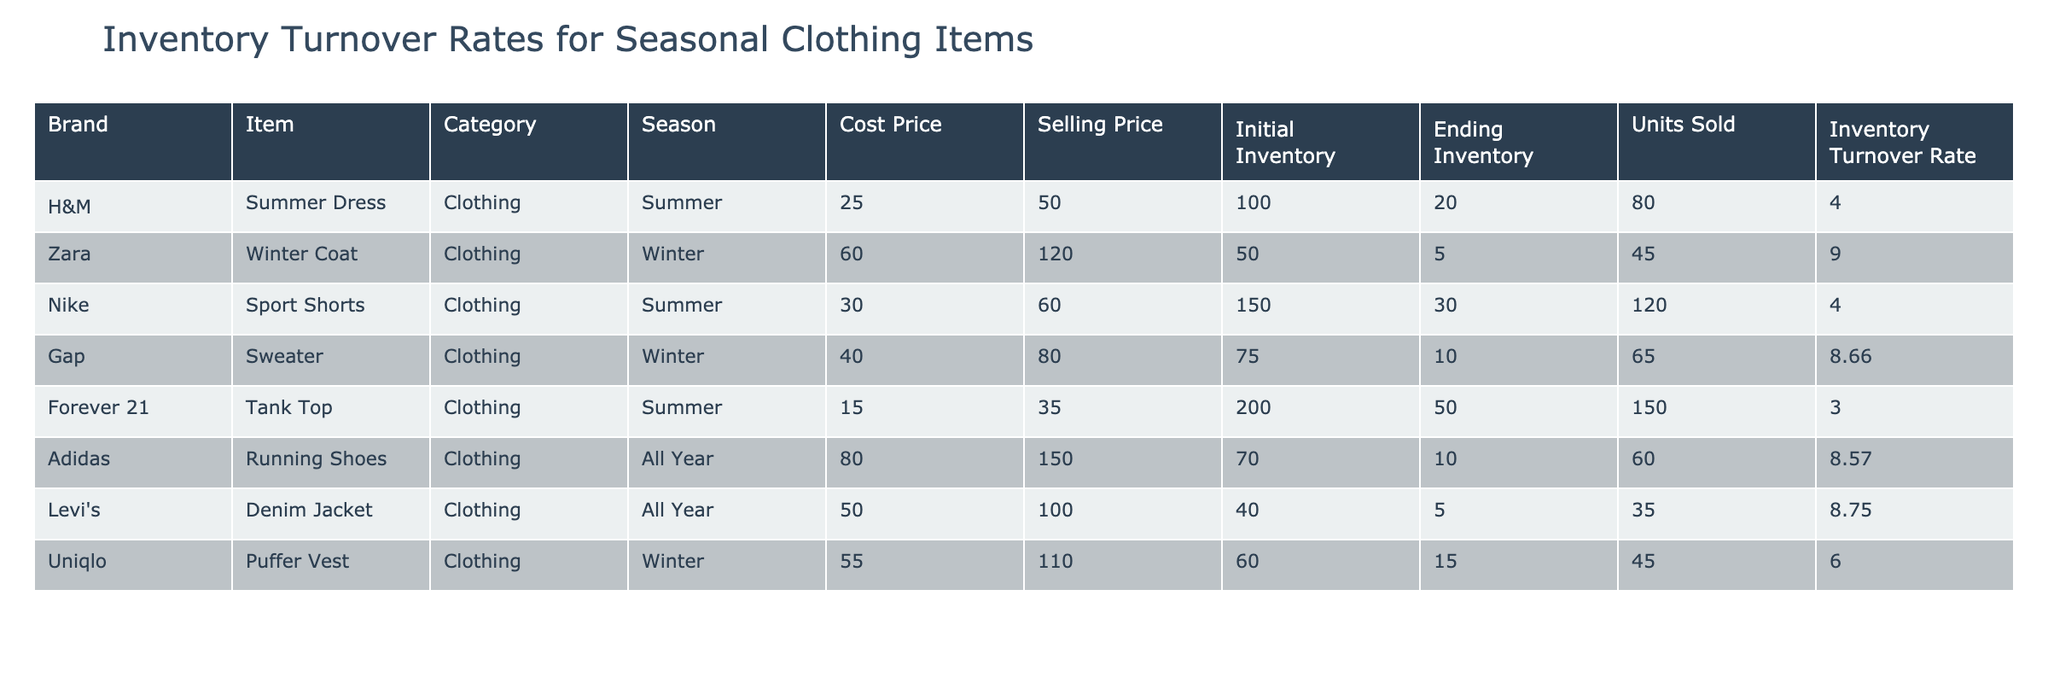What is the inventory turnover rate for the Summer Dress? The table shows that the inventory turnover rate for the Summer Dress from H&M is listed as 4.00.
Answer: 4.00 How many units of the Winter Coat were sold? According to the table, the number of units sold for the Winter Coat made by Zara is 45.
Answer: 45 Which clothing item has the highest inventory turnover rate? By examining the table, the Winter Coat has the highest turnover rate at 9.00, indicating it sold the most relative to its inventory.
Answer: Winter Coat If we add the units sold for all items in the Summer season, what is the total? The units sold for Summer items are 80 (Summer Dress) + 120 (Sport Shorts) + 150 (Tank Top) = 350.
Answer: 350 Is the selling price of the Puffer Vest higher than the selling price of the Tank Top? The table indicates that the selling price of the Puffer Vest is 110.00, while the selling price of the Tank Top is 35.00, so yes, the Puffer Vest is higher.
Answer: Yes Which item had the largest initial inventory? Upon reviewing the table, the item with the largest initial inventory is the Tank Top from Forever 21, which had an initial inventory of 200.
Answer: Tank Top What is the average selling price of all items listed in the table? To find the average, we first sum the selling prices: 50 + 120 + 60 + 80 + 35 + 150 + 100 + 110 = 705. There are 8 items, so the average selling price is 705 / 8 = 88.125.
Answer: 88.125 How many more units of the Sweater were sold compared to the Puffer Vest? The Sweater sold 65 units and the Puffer Vest sold 45 units. The difference is 65 - 45 = 20 units more sold for the Sweater.
Answer: 20 Is the inventory turnover rate for Running Shoes greater than that of the Denim Jacket? The inventory turnover rate for the Running Shoes is 8.57 and for the Denim Jacket it is 8.75. Since 8.57 is less than 8.75, the statement is false.
Answer: No 